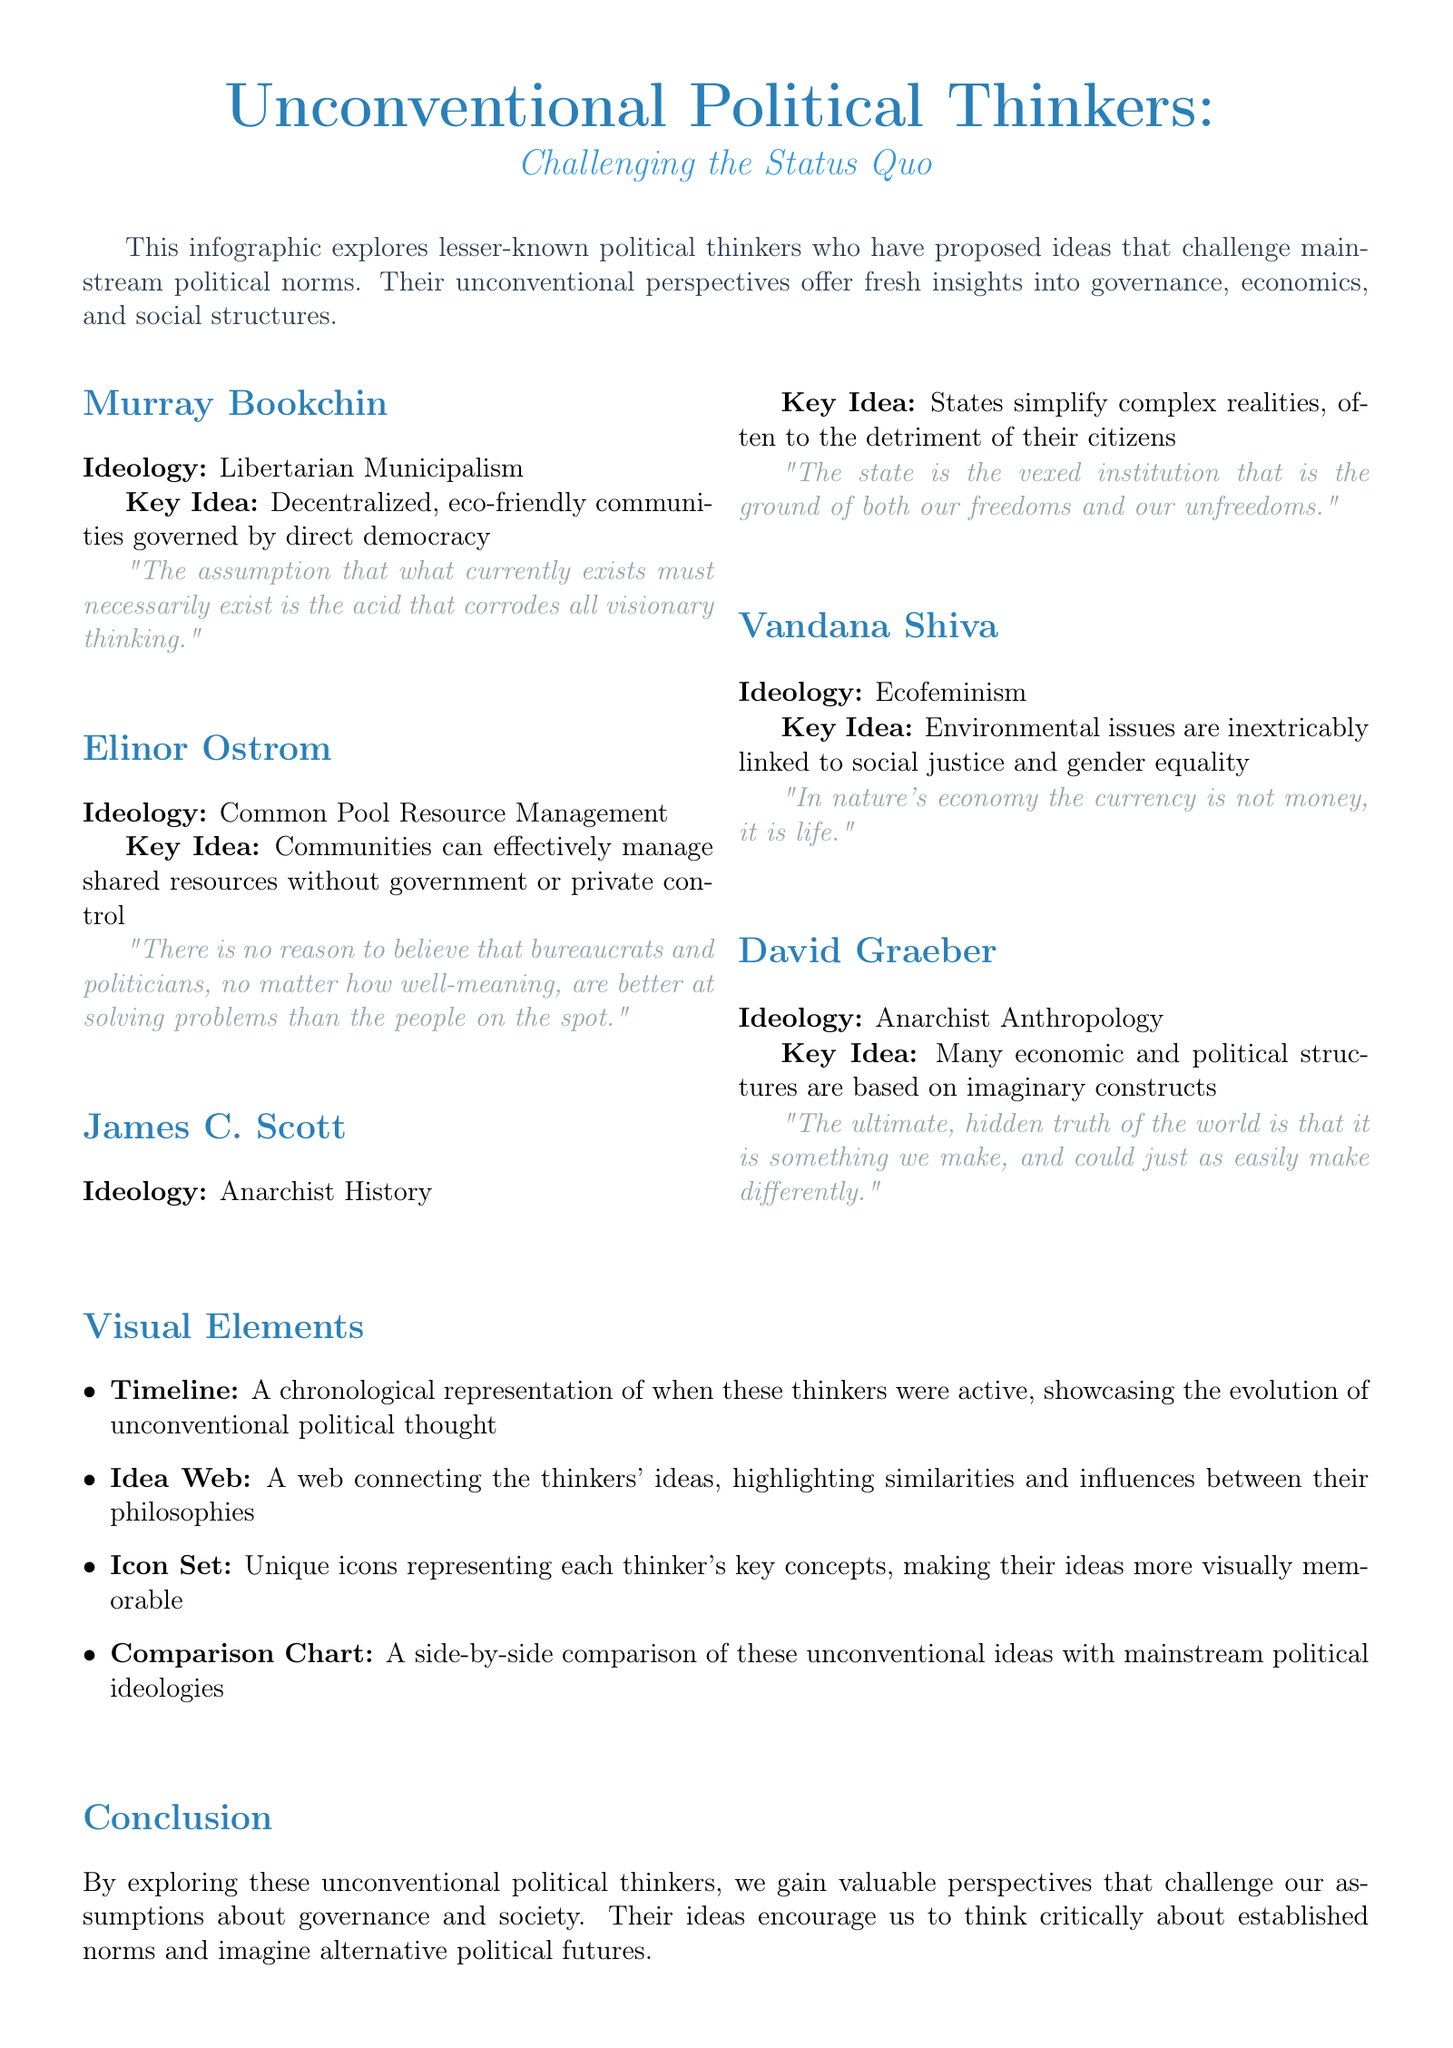What is the title of the newsletter? The title is explicitly mentioned at the beginning of the document.
Answer: Unconventional Political Thinkers: Challenging the Status Quo Who is the thinker associated with Ecofeminism? The document lists each thinker along with their ideology, where Ecofeminism is attributed to one specific individual.
Answer: Vandana Shiva What ideology does James C. Scott represent? The ideology section clearly specifies the ideology aligned with each thinker.
Answer: Anarchist History What is a unique visual element featured in the infographic? The document describes multiple visual elements used in the infographic format.
Answer: Idea Web According to Elinor Ostrom, what can communities manage effectively? The key idea section highlights what communities can handle without external control based on Ostrom's perspective.
Answer: Shared resources What is the key idea of David Graeber? The document provides a summarization of each thinker's key idea in the section dedicated to them.
Answer: Many economic and political structures are based on imaginary constructs What quote is attributed to Murray Bookchin? The notable quotes section provides a direct quote from each of the thinkers.
Answer: "The assumption that what currently exists must necessarily exist is the acid that corrodes all visionary thinking." What type of document is this? The specific type of document is highlighted in the introduction and throughout its purpose.
Answer: Newsletter 